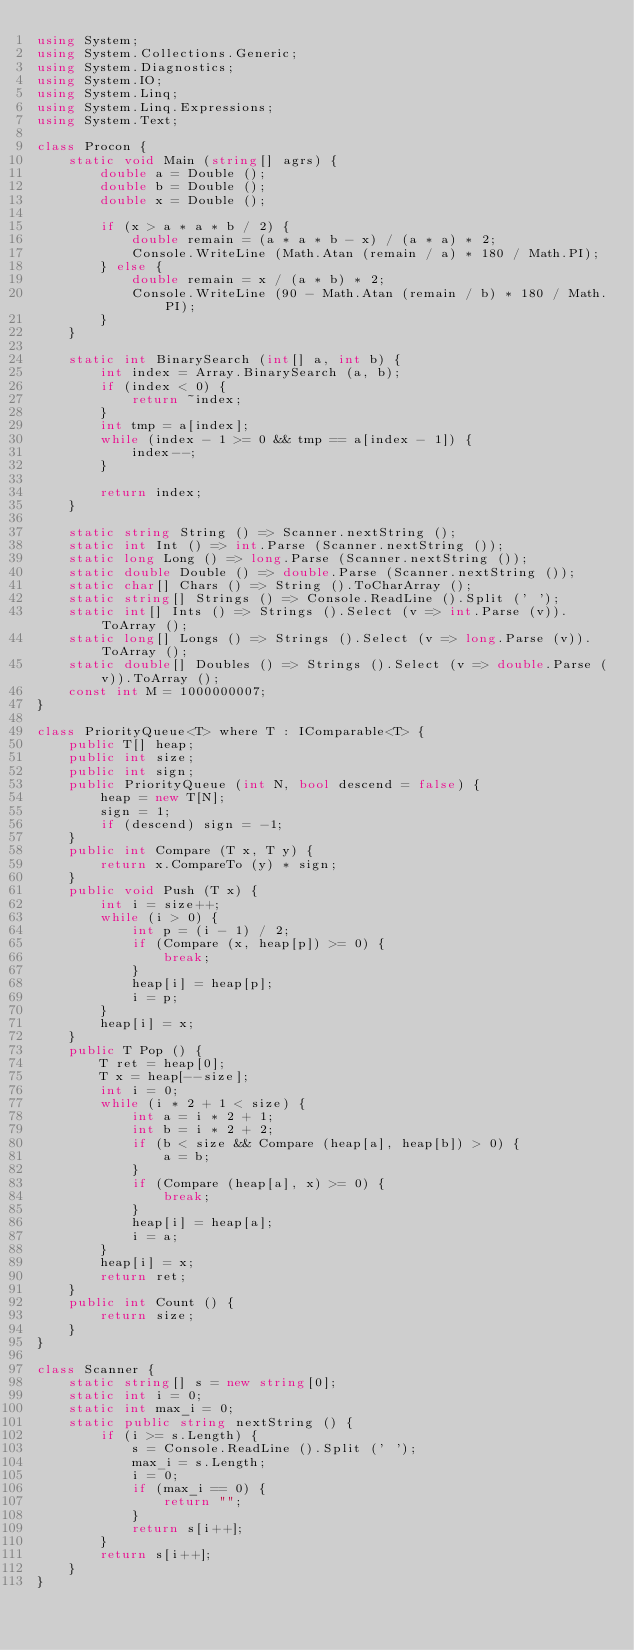<code> <loc_0><loc_0><loc_500><loc_500><_C#_>using System;
using System.Collections.Generic;
using System.Diagnostics;
using System.IO;
using System.Linq;
using System.Linq.Expressions;
using System.Text;

class Procon {
    static void Main (string[] agrs) {
        double a = Double ();
        double b = Double ();
        double x = Double ();

        if (x > a * a * b / 2) {
            double remain = (a * a * b - x) / (a * a) * 2;
            Console.WriteLine (Math.Atan (remain / a) * 180 / Math.PI);
        } else {
            double remain = x / (a * b) * 2;
            Console.WriteLine (90 - Math.Atan (remain / b) * 180 / Math.PI);
        }
    }

    static int BinarySearch (int[] a, int b) {
        int index = Array.BinarySearch (a, b);
        if (index < 0) {
            return ~index;
        }
        int tmp = a[index];
        while (index - 1 >= 0 && tmp == a[index - 1]) {
            index--;
        }

        return index;
    }

    static string String () => Scanner.nextString ();
    static int Int () => int.Parse (Scanner.nextString ());
    static long Long () => long.Parse (Scanner.nextString ());
    static double Double () => double.Parse (Scanner.nextString ());
    static char[] Chars () => String ().ToCharArray ();
    static string[] Strings () => Console.ReadLine ().Split (' ');
    static int[] Ints () => Strings ().Select (v => int.Parse (v)).ToArray ();
    static long[] Longs () => Strings ().Select (v => long.Parse (v)).ToArray ();
    static double[] Doubles () => Strings ().Select (v => double.Parse (v)).ToArray ();
    const int M = 1000000007;
}

class PriorityQueue<T> where T : IComparable<T> {
    public T[] heap;
    public int size;
    public int sign;
    public PriorityQueue (int N, bool descend = false) {
        heap = new T[N];
        sign = 1;
        if (descend) sign = -1;
    }
    public int Compare (T x, T y) {
        return x.CompareTo (y) * sign;
    }
    public void Push (T x) {
        int i = size++;
        while (i > 0) {
            int p = (i - 1) / 2;
            if (Compare (x, heap[p]) >= 0) {
                break;
            }
            heap[i] = heap[p];
            i = p;
        }
        heap[i] = x;
    }
    public T Pop () {
        T ret = heap[0];
        T x = heap[--size];
        int i = 0;
        while (i * 2 + 1 < size) {
            int a = i * 2 + 1;
            int b = i * 2 + 2;
            if (b < size && Compare (heap[a], heap[b]) > 0) {
                a = b;
            }
            if (Compare (heap[a], x) >= 0) {
                break;
            }
            heap[i] = heap[a];
            i = a;
        }
        heap[i] = x;
        return ret;
    }
    public int Count () {
        return size;
    }
}

class Scanner {
    static string[] s = new string[0];
    static int i = 0;
    static int max_i = 0;
    static public string nextString () {
        if (i >= s.Length) {
            s = Console.ReadLine ().Split (' ');
            max_i = s.Length;
            i = 0;
            if (max_i == 0) {
                return "";
            }
            return s[i++];
        }
        return s[i++];
    }
}</code> 